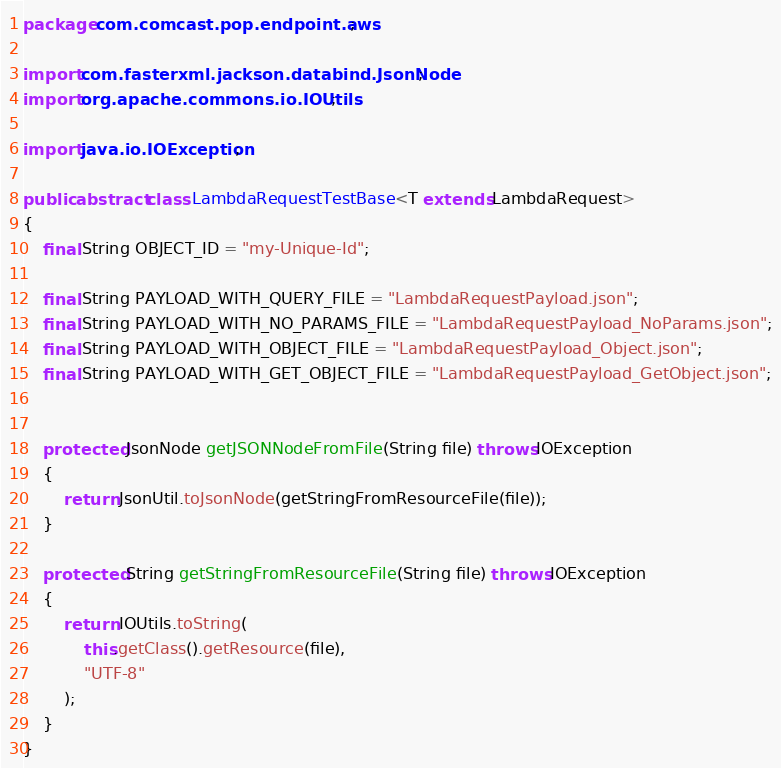<code> <loc_0><loc_0><loc_500><loc_500><_Java_>package com.comcast.pop.endpoint.aws;

import com.fasterxml.jackson.databind.JsonNode;
import org.apache.commons.io.IOUtils;

import java.io.IOException;

public abstract class LambdaRequestTestBase<T extends LambdaRequest>
{
    final String OBJECT_ID = "my-Unique-Id";

    final String PAYLOAD_WITH_QUERY_FILE = "LambdaRequestPayload.json";
    final String PAYLOAD_WITH_NO_PARAMS_FILE = "LambdaRequestPayload_NoParams.json";
    final String PAYLOAD_WITH_OBJECT_FILE = "LambdaRequestPayload_Object.json";
    final String PAYLOAD_WITH_GET_OBJECT_FILE = "LambdaRequestPayload_GetObject.json";


    protected JsonNode getJSONNodeFromFile(String file) throws IOException
    {
        return JsonUtil.toJsonNode(getStringFromResourceFile(file));
    }

    protected String getStringFromResourceFile(String file) throws IOException
    {
        return IOUtils.toString(
            this.getClass().getResource(file),
            "UTF-8"
        );
    }
}
</code> 